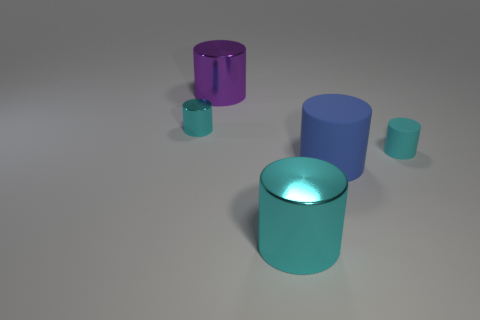There is a big cyan thing; what number of metal things are on the left side of it?
Give a very brief answer. 2. What size is the matte cylinder left of the small cyan rubber cylinder that is in front of the small cylinder on the left side of the big rubber object?
Your answer should be compact. Large. Are there any blue matte cylinders to the right of the small object that is left of the big shiny thing that is behind the big cyan metallic cylinder?
Ensure brevity in your answer.  Yes. Is the number of large purple cubes greater than the number of big blue matte objects?
Your answer should be very brief. No. There is a big object that is behind the blue matte object; what color is it?
Offer a very short reply. Purple. Are there more cyan metallic objects in front of the cyan rubber cylinder than small cyan metal blocks?
Your response must be concise. Yes. Do the large purple cylinder and the large cyan cylinder have the same material?
Ensure brevity in your answer.  Yes. What number of other objects are the same shape as the big blue thing?
Keep it short and to the point. 4. The metallic cylinder in front of the blue thing in front of the rubber thing to the right of the blue cylinder is what color?
Keep it short and to the point. Cyan. There is a small object on the left side of the big cyan shiny cylinder; is it the same shape as the big blue rubber thing?
Give a very brief answer. Yes. 